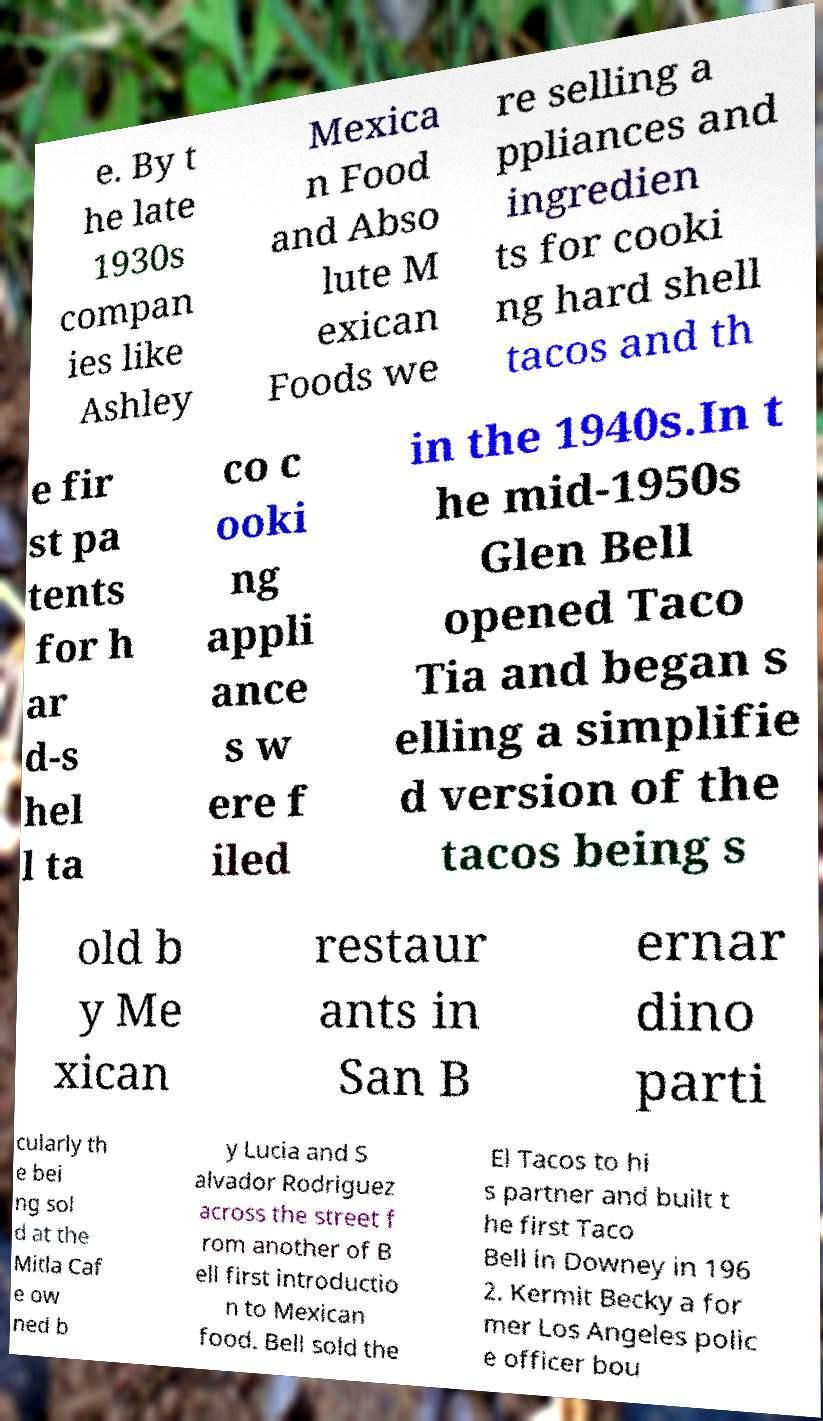There's text embedded in this image that I need extracted. Can you transcribe it verbatim? e. By t he late 1930s compan ies like Ashley Mexica n Food and Abso lute M exican Foods we re selling a ppliances and ingredien ts for cooki ng hard shell tacos and th e fir st pa tents for h ar d-s hel l ta co c ooki ng appli ance s w ere f iled in the 1940s.In t he mid-1950s Glen Bell opened Taco Tia and began s elling a simplifie d version of the tacos being s old b y Me xican restaur ants in San B ernar dino parti cularly th e bei ng sol d at the Mitla Caf e ow ned b y Lucia and S alvador Rodriguez across the street f rom another of B ell first introductio n to Mexican food. Bell sold the El Tacos to hi s partner and built t he first Taco Bell in Downey in 196 2. Kermit Becky a for mer Los Angeles polic e officer bou 